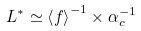Convert formula to latex. <formula><loc_0><loc_0><loc_500><loc_500>L ^ { * } \simeq \left < f \right > ^ { - 1 } \times \alpha _ { c } ^ { - 1 }</formula> 